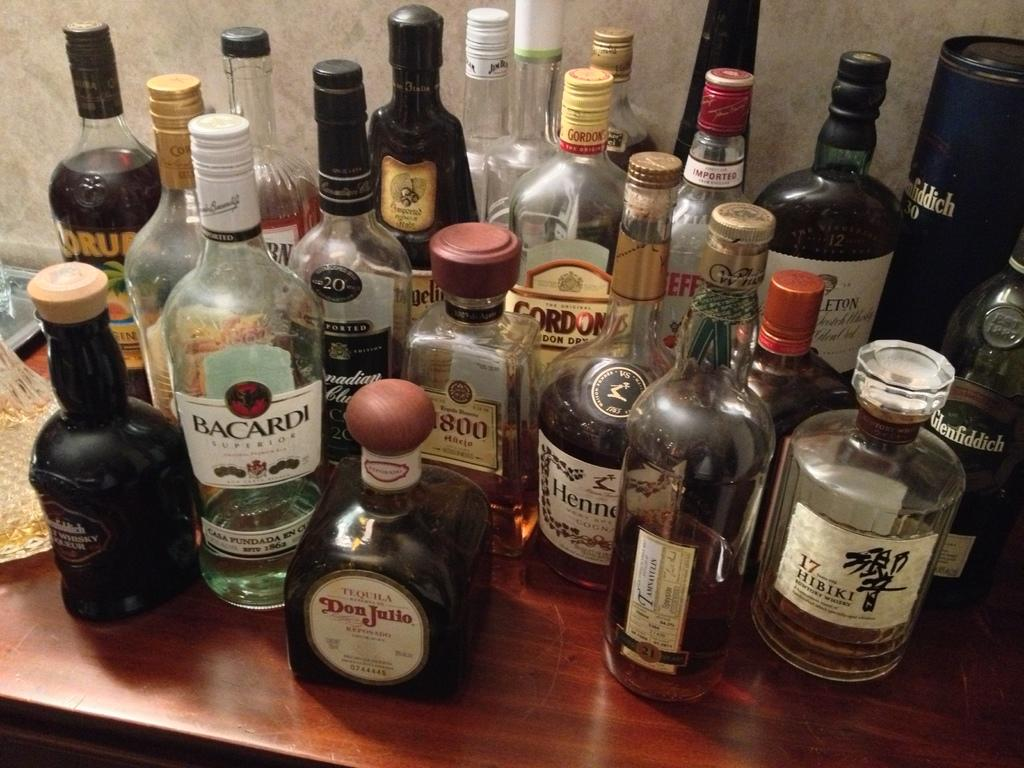<image>
Offer a succinct explanation of the picture presented. table top full of full and empty alcohol bottles such as bacardi, don julio tequila and 17 hibiki 